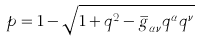<formula> <loc_0><loc_0><loc_500><loc_500>p = 1 - \sqrt { 1 + q ^ { 2 } - \overset { \_ } { g } _ { \alpha \nu } q ^ { \alpha } q ^ { \nu } }</formula> 